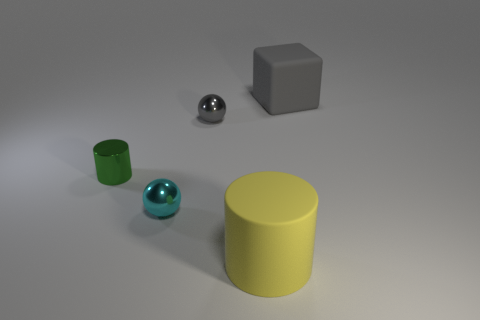Add 2 small cyan objects. How many objects exist? 7 Subtract all cylinders. How many objects are left? 3 Add 5 red shiny cylinders. How many red shiny cylinders exist? 5 Subtract 0 red cylinders. How many objects are left? 5 Subtract all purple cylinders. Subtract all cyan things. How many objects are left? 4 Add 2 gray metallic things. How many gray metallic things are left? 3 